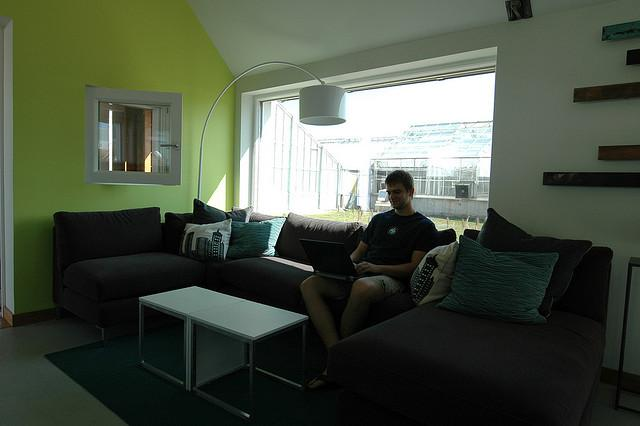What are his fingers touching?

Choices:
A) legs
B) charger
C) keyboard
D) screen keyboard 